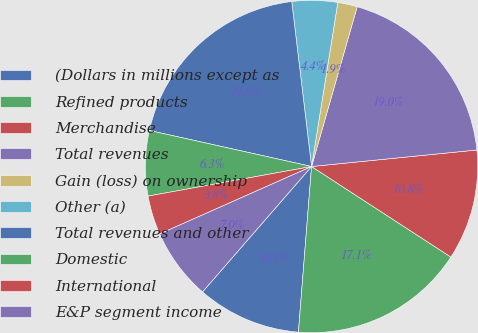Convert chart. <chart><loc_0><loc_0><loc_500><loc_500><pie_chart><fcel>(Dollars in millions except as<fcel>Refined products<fcel>Merchandise<fcel>Total revenues<fcel>Gain (loss) on ownership<fcel>Other (a)<fcel>Total revenues and other<fcel>Domestic<fcel>International<fcel>E&P segment income<nl><fcel>10.13%<fcel>17.09%<fcel>10.76%<fcel>18.99%<fcel>1.9%<fcel>4.43%<fcel>19.62%<fcel>6.33%<fcel>3.8%<fcel>6.96%<nl></chart> 